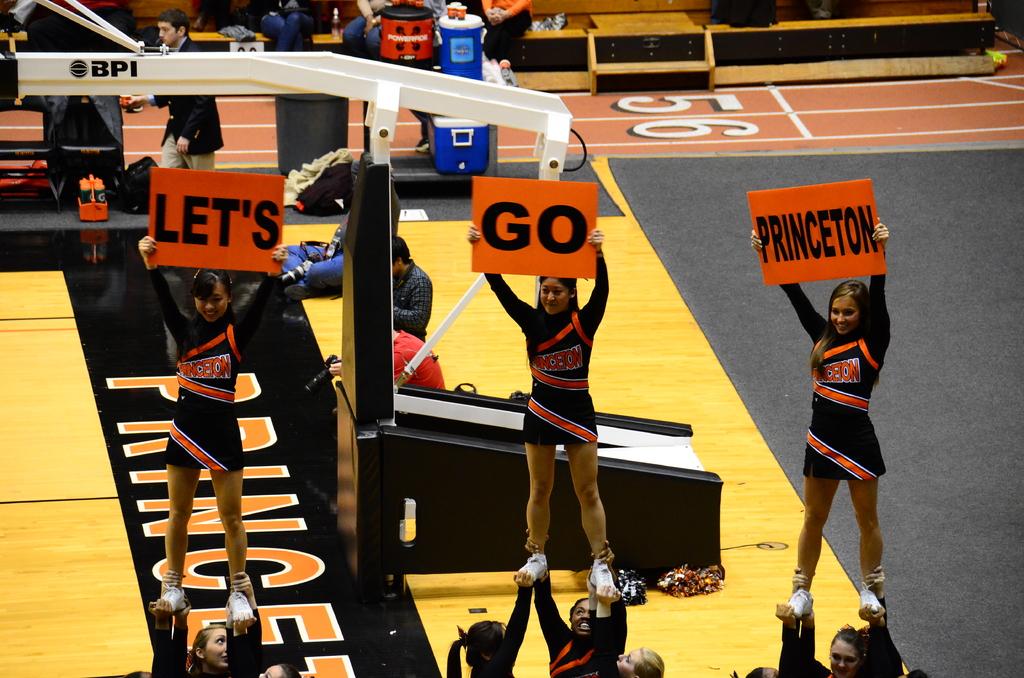What are the cheerleaders telling princeton to do?
Provide a short and direct response. Go. 